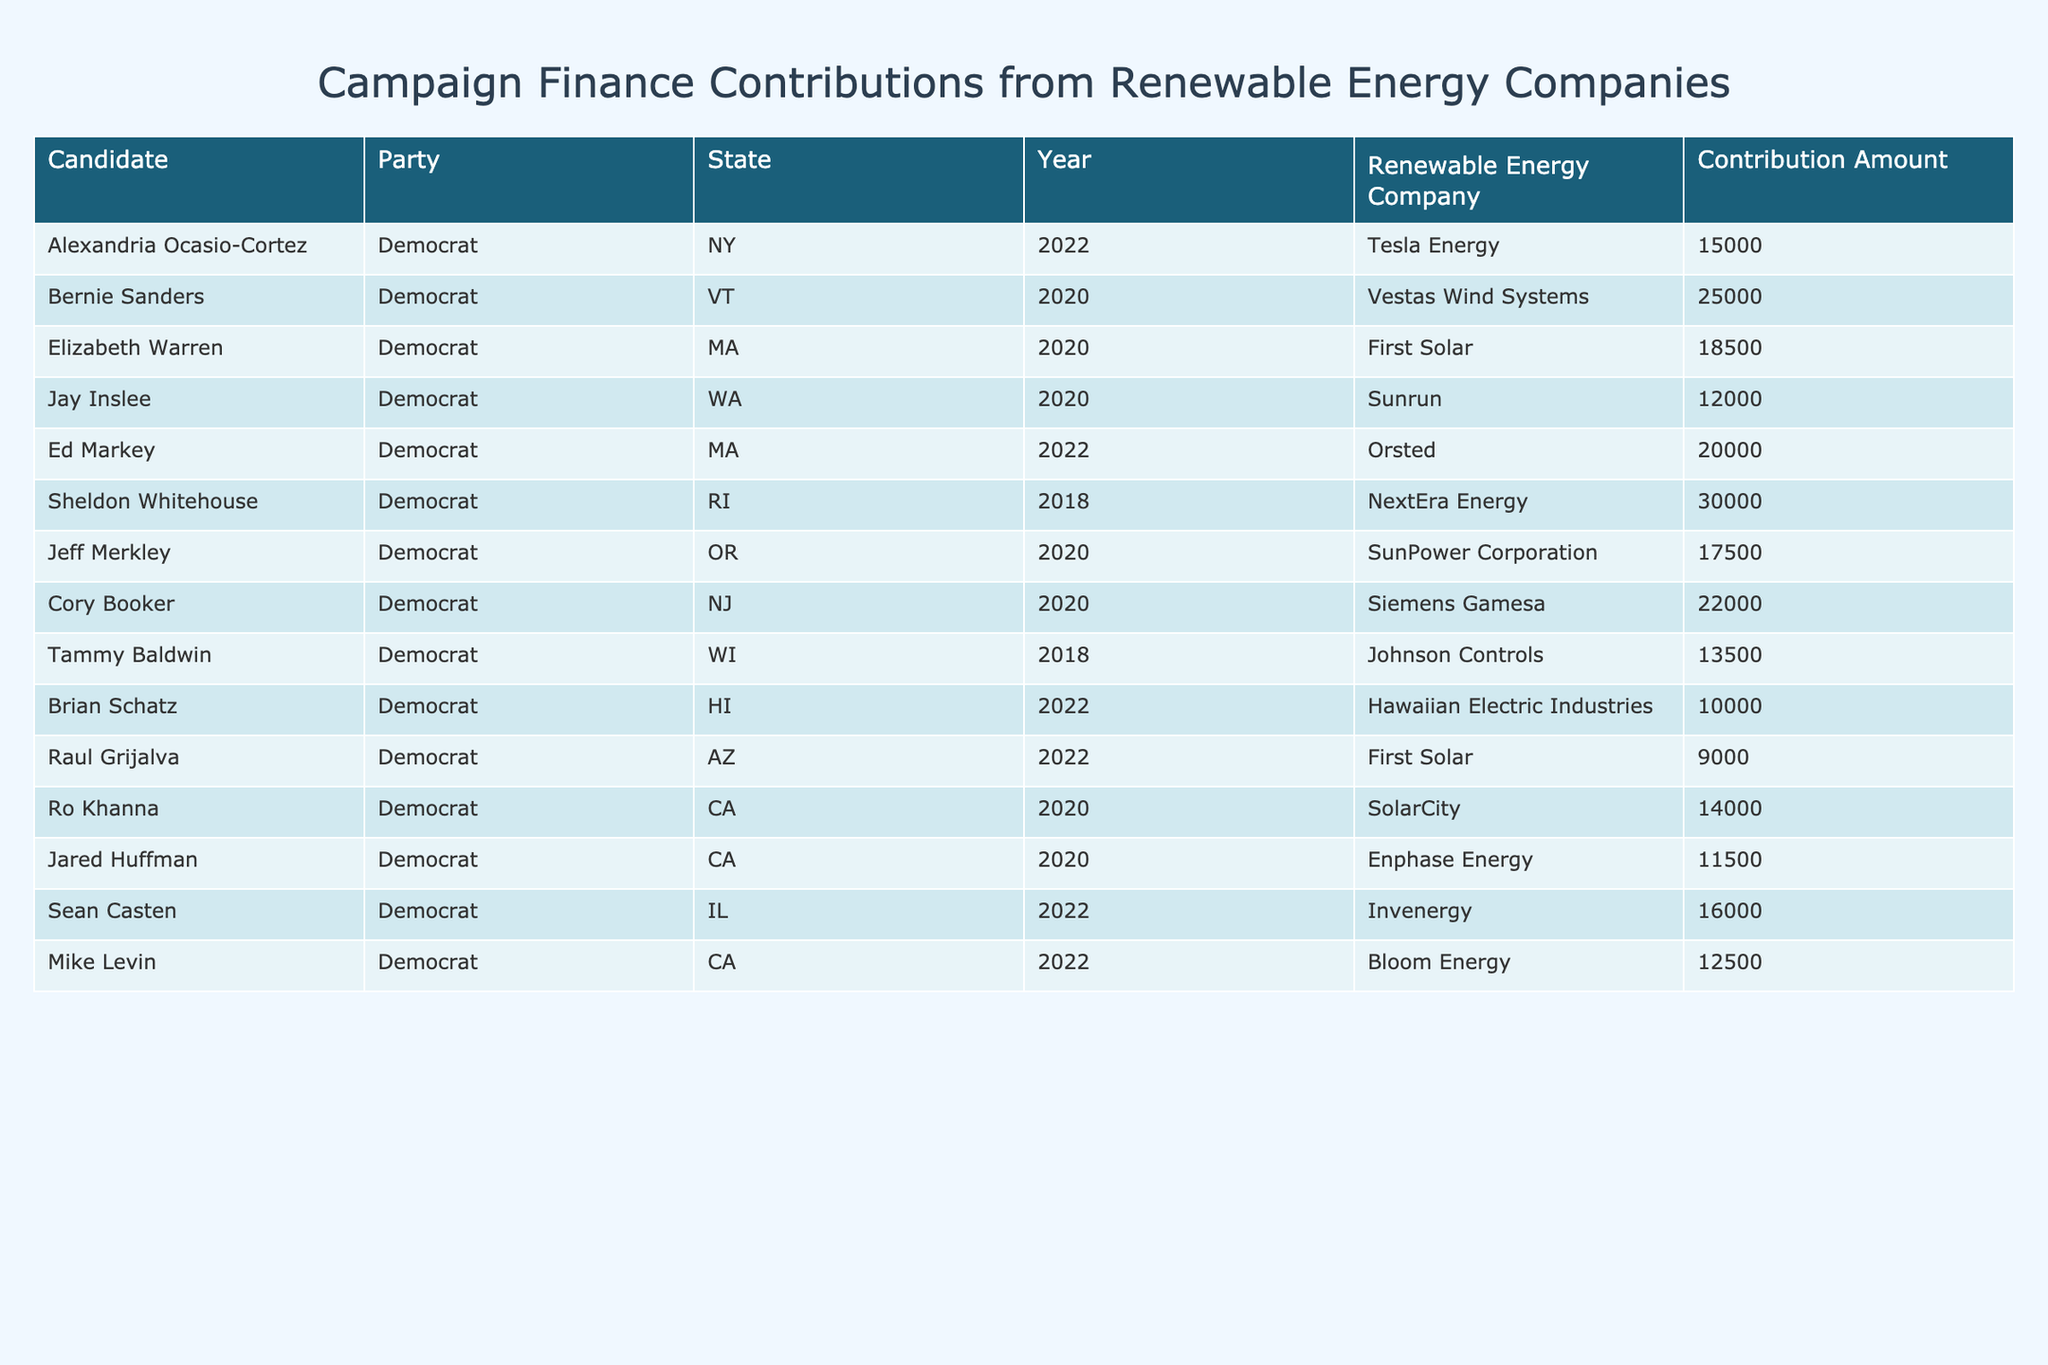What is the contribution amount from Tesla Energy? By scanning the table for the row with "Tesla Energy," I see that the contribution amount listed next to Alexandria Ocasio-Cortez is $15,000.
Answer: $15,000 Who received the highest contribution from a renewable energy company? Looking through the contributions listed, Sheldon Whitehouse received the highest contribution amount of $30,000 from NextEra Energy.
Answer: $30,000 How many candidates received contributions from First Solar? I count the rows where First Solar is mentioned, which are two: Elizabeth Warren in 2020 and Raul Grijalva in 2022. Therefore, the total is 2 candidates.
Answer: 2 What is the total contribution amount received by candidates from Siemens Gamesa? The only candidate mentioned with contributions from Siemens Gamesa is Cory Booker, who received $22,000. Hence, the total is $22,000.
Answer: $22,000 What is the average contribution amount for candidates from the state of California? The candidates from California are Ro Khanna, Jared Huffman, and Mike Levin with contributions of $14,000, $11,500, and $12,500 respectively. The total is $14,000 + $11,500 + $12,500 = $38,000; dividing by 3 candidates gives an average of $38,000 / 3 = $12,666.67.
Answer: $12,666.67 Did any candidate receive less than $10,000 in contributions? I review the table and find that the lowest contribution listed is $9,000 from Raul Grijalva, confirming that at least one candidate received less than $10,000.
Answer: Yes What is the total contribution from renewable energy companies to Democrat candidates in 2022? The candidates in 2022 are Alexandria Ocasio-Cortez ($15,000), Ed Markey ($20,000), Brian Schatz ($10,000), and Sean Casten ($16,000). Summing these gives $15,000 + $20,000 + $10,000 + $16,000 = $61,000.
Answer: $61,000 Which state contributed the least amount overall? Summing contributions by state: New York (AOC: $15,000), Vermont (Sanders: $25,000), Massachusetts (Warren: $18,500, Markey: $20,000), Washington (Inslee: $12,000), and others. The lowest total is from Wisconsin with $13,500 from Tammy Baldwin.
Answer: Wisconsin Are there any candidates who received contributions from multiple renewable energy companies? Reviewing the table reveals that each candidate appears only once with their contributions from one renewable energy company. Therefore, there are no candidates with contributions from multiple companies.
Answer: No What is the total amount contributed by Orsted? The only candidate with a contribution from Orsted is Ed Markey, who received $20,000. Thus, the total is $20,000.
Answer: $20,000 